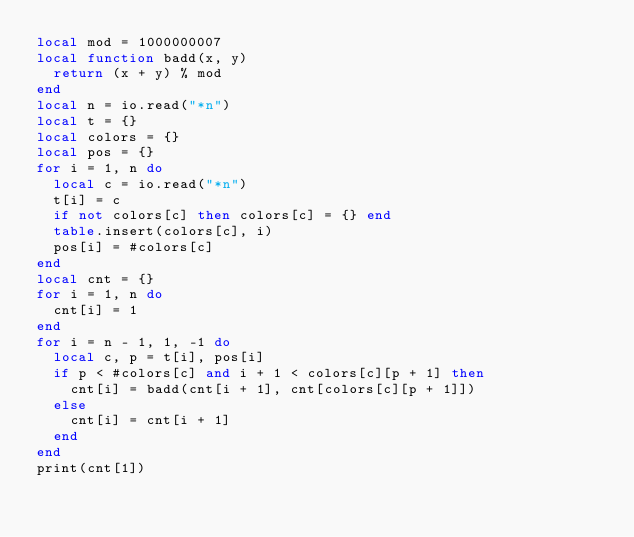<code> <loc_0><loc_0><loc_500><loc_500><_Lua_>local mod = 1000000007
local function badd(x, y)
  return (x + y) % mod
end
local n = io.read("*n")
local t = {}
local colors = {}
local pos = {}
for i = 1, n do
  local c = io.read("*n")
  t[i] = c
  if not colors[c] then colors[c] = {} end
  table.insert(colors[c], i)
  pos[i] = #colors[c]
end
local cnt = {}
for i = 1, n do
  cnt[i] = 1
end
for i = n - 1, 1, -1 do
  local c, p = t[i], pos[i]
  if p < #colors[c] and i + 1 < colors[c][p + 1] then
    cnt[i] = badd(cnt[i + 1], cnt[colors[c][p + 1]])
  else
    cnt[i] = cnt[i + 1]
  end
end
print(cnt[1])
</code> 